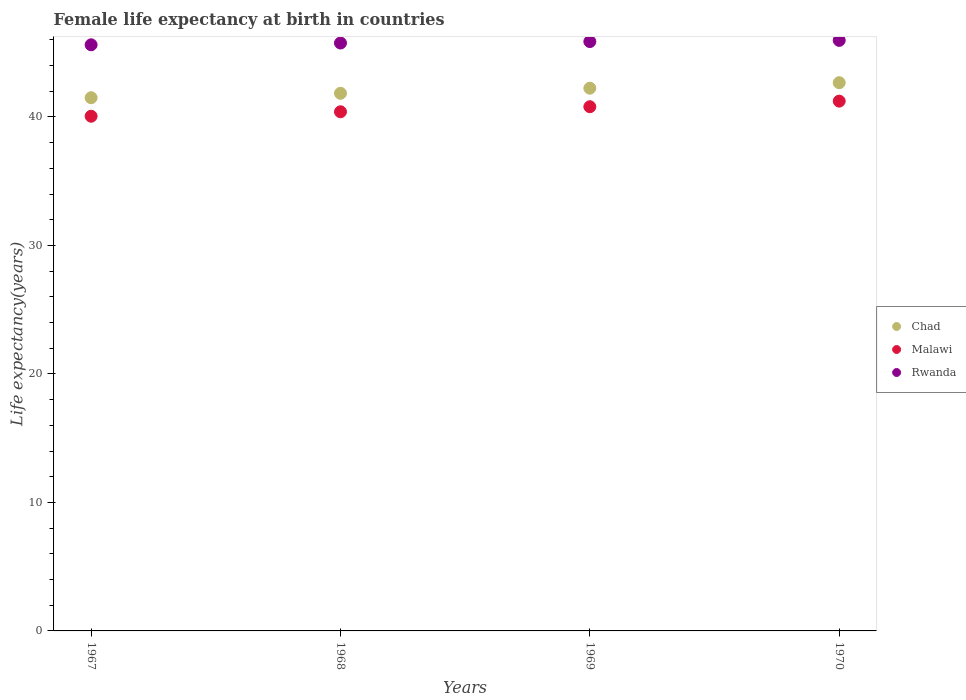How many different coloured dotlines are there?
Offer a terse response. 3. Is the number of dotlines equal to the number of legend labels?
Offer a terse response. Yes. What is the female life expectancy at birth in Malawi in 1969?
Your response must be concise. 40.8. Across all years, what is the maximum female life expectancy at birth in Malawi?
Your answer should be very brief. 41.23. Across all years, what is the minimum female life expectancy at birth in Chad?
Your response must be concise. 41.5. In which year was the female life expectancy at birth in Malawi minimum?
Make the answer very short. 1967. What is the total female life expectancy at birth in Chad in the graph?
Your response must be concise. 168.24. What is the difference between the female life expectancy at birth in Malawi in 1968 and that in 1970?
Your answer should be very brief. -0.83. What is the difference between the female life expectancy at birth in Rwanda in 1970 and the female life expectancy at birth in Chad in 1968?
Keep it short and to the point. 4.12. What is the average female life expectancy at birth in Malawi per year?
Provide a succinct answer. 40.62. In the year 1970, what is the difference between the female life expectancy at birth in Malawi and female life expectancy at birth in Rwanda?
Your answer should be very brief. -4.73. In how many years, is the female life expectancy at birth in Rwanda greater than 22 years?
Make the answer very short. 4. What is the ratio of the female life expectancy at birth in Chad in 1969 to that in 1970?
Give a very brief answer. 0.99. Is the female life expectancy at birth in Chad in 1967 less than that in 1970?
Make the answer very short. Yes. Is the difference between the female life expectancy at birth in Malawi in 1967 and 1970 greater than the difference between the female life expectancy at birth in Rwanda in 1967 and 1970?
Your answer should be very brief. No. What is the difference between the highest and the second highest female life expectancy at birth in Chad?
Offer a very short reply. 0.43. What is the difference between the highest and the lowest female life expectancy at birth in Chad?
Your answer should be very brief. 1.17. In how many years, is the female life expectancy at birth in Rwanda greater than the average female life expectancy at birth in Rwanda taken over all years?
Offer a very short reply. 2. Is it the case that in every year, the sum of the female life expectancy at birth in Malawi and female life expectancy at birth in Rwanda  is greater than the female life expectancy at birth in Chad?
Make the answer very short. Yes. Is the female life expectancy at birth in Chad strictly less than the female life expectancy at birth in Malawi over the years?
Offer a very short reply. No. How many years are there in the graph?
Give a very brief answer. 4. Are the values on the major ticks of Y-axis written in scientific E-notation?
Provide a short and direct response. No. Does the graph contain grids?
Offer a terse response. No. How are the legend labels stacked?
Your answer should be compact. Vertical. What is the title of the graph?
Make the answer very short. Female life expectancy at birth in countries. Does "Lithuania" appear as one of the legend labels in the graph?
Provide a succinct answer. No. What is the label or title of the Y-axis?
Give a very brief answer. Life expectancy(years). What is the Life expectancy(years) in Chad in 1967?
Your answer should be very brief. 41.5. What is the Life expectancy(years) in Malawi in 1967?
Your response must be concise. 40.05. What is the Life expectancy(years) in Rwanda in 1967?
Make the answer very short. 45.61. What is the Life expectancy(years) in Chad in 1968?
Offer a terse response. 41.84. What is the Life expectancy(years) in Malawi in 1968?
Make the answer very short. 40.4. What is the Life expectancy(years) of Rwanda in 1968?
Your response must be concise. 45.75. What is the Life expectancy(years) in Chad in 1969?
Offer a terse response. 42.24. What is the Life expectancy(years) in Malawi in 1969?
Ensure brevity in your answer.  40.8. What is the Life expectancy(years) in Rwanda in 1969?
Provide a succinct answer. 45.87. What is the Life expectancy(years) of Chad in 1970?
Keep it short and to the point. 42.66. What is the Life expectancy(years) in Malawi in 1970?
Provide a short and direct response. 41.23. What is the Life expectancy(years) of Rwanda in 1970?
Provide a succinct answer. 45.96. Across all years, what is the maximum Life expectancy(years) in Chad?
Make the answer very short. 42.66. Across all years, what is the maximum Life expectancy(years) of Malawi?
Ensure brevity in your answer.  41.23. Across all years, what is the maximum Life expectancy(years) of Rwanda?
Give a very brief answer. 45.96. Across all years, what is the minimum Life expectancy(years) in Chad?
Give a very brief answer. 41.5. Across all years, what is the minimum Life expectancy(years) in Malawi?
Your answer should be compact. 40.05. Across all years, what is the minimum Life expectancy(years) of Rwanda?
Offer a terse response. 45.61. What is the total Life expectancy(years) of Chad in the graph?
Your answer should be very brief. 168.24. What is the total Life expectancy(years) in Malawi in the graph?
Keep it short and to the point. 162.48. What is the total Life expectancy(years) of Rwanda in the graph?
Keep it short and to the point. 183.19. What is the difference between the Life expectancy(years) in Chad in 1967 and that in 1968?
Provide a succinct answer. -0.34. What is the difference between the Life expectancy(years) in Malawi in 1967 and that in 1968?
Your answer should be compact. -0.35. What is the difference between the Life expectancy(years) in Rwanda in 1967 and that in 1968?
Your answer should be compact. -0.14. What is the difference between the Life expectancy(years) in Chad in 1967 and that in 1969?
Give a very brief answer. -0.74. What is the difference between the Life expectancy(years) of Malawi in 1967 and that in 1969?
Ensure brevity in your answer.  -0.74. What is the difference between the Life expectancy(years) in Rwanda in 1967 and that in 1969?
Your answer should be compact. -0.25. What is the difference between the Life expectancy(years) in Chad in 1967 and that in 1970?
Ensure brevity in your answer.  -1.17. What is the difference between the Life expectancy(years) in Malawi in 1967 and that in 1970?
Offer a terse response. -1.18. What is the difference between the Life expectancy(years) in Rwanda in 1967 and that in 1970?
Keep it short and to the point. -0.34. What is the difference between the Life expectancy(years) in Chad in 1968 and that in 1969?
Offer a very short reply. -0.4. What is the difference between the Life expectancy(years) in Malawi in 1968 and that in 1969?
Your answer should be compact. -0.39. What is the difference between the Life expectancy(years) in Rwanda in 1968 and that in 1969?
Keep it short and to the point. -0.11. What is the difference between the Life expectancy(years) of Chad in 1968 and that in 1970?
Offer a very short reply. -0.82. What is the difference between the Life expectancy(years) of Malawi in 1968 and that in 1970?
Provide a short and direct response. -0.83. What is the difference between the Life expectancy(years) in Rwanda in 1968 and that in 1970?
Your answer should be compact. -0.21. What is the difference between the Life expectancy(years) of Chad in 1969 and that in 1970?
Offer a very short reply. -0.43. What is the difference between the Life expectancy(years) of Malawi in 1969 and that in 1970?
Your answer should be compact. -0.44. What is the difference between the Life expectancy(years) in Rwanda in 1969 and that in 1970?
Ensure brevity in your answer.  -0.09. What is the difference between the Life expectancy(years) in Chad in 1967 and the Life expectancy(years) in Malawi in 1968?
Your answer should be very brief. 1.09. What is the difference between the Life expectancy(years) of Chad in 1967 and the Life expectancy(years) of Rwanda in 1968?
Provide a short and direct response. -4.26. What is the difference between the Life expectancy(years) of Malawi in 1967 and the Life expectancy(years) of Rwanda in 1968?
Your answer should be very brief. -5.7. What is the difference between the Life expectancy(years) in Chad in 1967 and the Life expectancy(years) in Malawi in 1969?
Your answer should be very brief. 0.7. What is the difference between the Life expectancy(years) in Chad in 1967 and the Life expectancy(years) in Rwanda in 1969?
Ensure brevity in your answer.  -4.37. What is the difference between the Life expectancy(years) in Malawi in 1967 and the Life expectancy(years) in Rwanda in 1969?
Provide a succinct answer. -5.81. What is the difference between the Life expectancy(years) of Chad in 1967 and the Life expectancy(years) of Malawi in 1970?
Keep it short and to the point. 0.27. What is the difference between the Life expectancy(years) of Chad in 1967 and the Life expectancy(years) of Rwanda in 1970?
Offer a terse response. -4.46. What is the difference between the Life expectancy(years) in Malawi in 1967 and the Life expectancy(years) in Rwanda in 1970?
Your answer should be compact. -5.9. What is the difference between the Life expectancy(years) in Chad in 1968 and the Life expectancy(years) in Malawi in 1969?
Offer a terse response. 1.05. What is the difference between the Life expectancy(years) in Chad in 1968 and the Life expectancy(years) in Rwanda in 1969?
Provide a succinct answer. -4.03. What is the difference between the Life expectancy(years) in Malawi in 1968 and the Life expectancy(years) in Rwanda in 1969?
Provide a succinct answer. -5.46. What is the difference between the Life expectancy(years) of Chad in 1968 and the Life expectancy(years) of Malawi in 1970?
Make the answer very short. 0.61. What is the difference between the Life expectancy(years) of Chad in 1968 and the Life expectancy(years) of Rwanda in 1970?
Provide a succinct answer. -4.12. What is the difference between the Life expectancy(years) of Malawi in 1968 and the Life expectancy(years) of Rwanda in 1970?
Keep it short and to the point. -5.56. What is the difference between the Life expectancy(years) of Chad in 1969 and the Life expectancy(years) of Rwanda in 1970?
Keep it short and to the point. -3.72. What is the difference between the Life expectancy(years) of Malawi in 1969 and the Life expectancy(years) of Rwanda in 1970?
Ensure brevity in your answer.  -5.16. What is the average Life expectancy(years) in Chad per year?
Offer a very short reply. 42.06. What is the average Life expectancy(years) in Malawi per year?
Provide a short and direct response. 40.62. What is the average Life expectancy(years) of Rwanda per year?
Keep it short and to the point. 45.8. In the year 1967, what is the difference between the Life expectancy(years) of Chad and Life expectancy(years) of Malawi?
Make the answer very short. 1.44. In the year 1967, what is the difference between the Life expectancy(years) of Chad and Life expectancy(years) of Rwanda?
Offer a very short reply. -4.12. In the year 1967, what is the difference between the Life expectancy(years) in Malawi and Life expectancy(years) in Rwanda?
Offer a terse response. -5.56. In the year 1968, what is the difference between the Life expectancy(years) of Chad and Life expectancy(years) of Malawi?
Ensure brevity in your answer.  1.44. In the year 1968, what is the difference between the Life expectancy(years) of Chad and Life expectancy(years) of Rwanda?
Offer a very short reply. -3.91. In the year 1968, what is the difference between the Life expectancy(years) in Malawi and Life expectancy(years) in Rwanda?
Give a very brief answer. -5.35. In the year 1969, what is the difference between the Life expectancy(years) in Chad and Life expectancy(years) in Malawi?
Your response must be concise. 1.44. In the year 1969, what is the difference between the Life expectancy(years) of Chad and Life expectancy(years) of Rwanda?
Ensure brevity in your answer.  -3.63. In the year 1969, what is the difference between the Life expectancy(years) in Malawi and Life expectancy(years) in Rwanda?
Offer a very short reply. -5.07. In the year 1970, what is the difference between the Life expectancy(years) in Chad and Life expectancy(years) in Malawi?
Offer a terse response. 1.43. In the year 1970, what is the difference between the Life expectancy(years) in Chad and Life expectancy(years) in Rwanda?
Give a very brief answer. -3.29. In the year 1970, what is the difference between the Life expectancy(years) in Malawi and Life expectancy(years) in Rwanda?
Your response must be concise. -4.73. What is the ratio of the Life expectancy(years) of Chad in 1967 to that in 1968?
Your answer should be compact. 0.99. What is the ratio of the Life expectancy(years) of Malawi in 1967 to that in 1968?
Keep it short and to the point. 0.99. What is the ratio of the Life expectancy(years) in Chad in 1967 to that in 1969?
Offer a very short reply. 0.98. What is the ratio of the Life expectancy(years) of Malawi in 1967 to that in 1969?
Keep it short and to the point. 0.98. What is the ratio of the Life expectancy(years) of Rwanda in 1967 to that in 1969?
Your answer should be compact. 0.99. What is the ratio of the Life expectancy(years) of Chad in 1967 to that in 1970?
Make the answer very short. 0.97. What is the ratio of the Life expectancy(years) in Malawi in 1967 to that in 1970?
Ensure brevity in your answer.  0.97. What is the ratio of the Life expectancy(years) in Chad in 1968 to that in 1969?
Keep it short and to the point. 0.99. What is the ratio of the Life expectancy(years) of Malawi in 1968 to that in 1969?
Keep it short and to the point. 0.99. What is the ratio of the Life expectancy(years) in Chad in 1968 to that in 1970?
Offer a very short reply. 0.98. What is the ratio of the Life expectancy(years) of Malawi in 1968 to that in 1970?
Offer a terse response. 0.98. What is the ratio of the Life expectancy(years) of Rwanda in 1968 to that in 1970?
Your answer should be very brief. 1. What is the ratio of the Life expectancy(years) of Chad in 1969 to that in 1970?
Keep it short and to the point. 0.99. What is the ratio of the Life expectancy(years) in Malawi in 1969 to that in 1970?
Ensure brevity in your answer.  0.99. What is the difference between the highest and the second highest Life expectancy(years) in Chad?
Keep it short and to the point. 0.43. What is the difference between the highest and the second highest Life expectancy(years) in Malawi?
Keep it short and to the point. 0.44. What is the difference between the highest and the second highest Life expectancy(years) of Rwanda?
Your response must be concise. 0.09. What is the difference between the highest and the lowest Life expectancy(years) in Chad?
Your answer should be very brief. 1.17. What is the difference between the highest and the lowest Life expectancy(years) of Malawi?
Your answer should be very brief. 1.18. What is the difference between the highest and the lowest Life expectancy(years) of Rwanda?
Your answer should be compact. 0.34. 